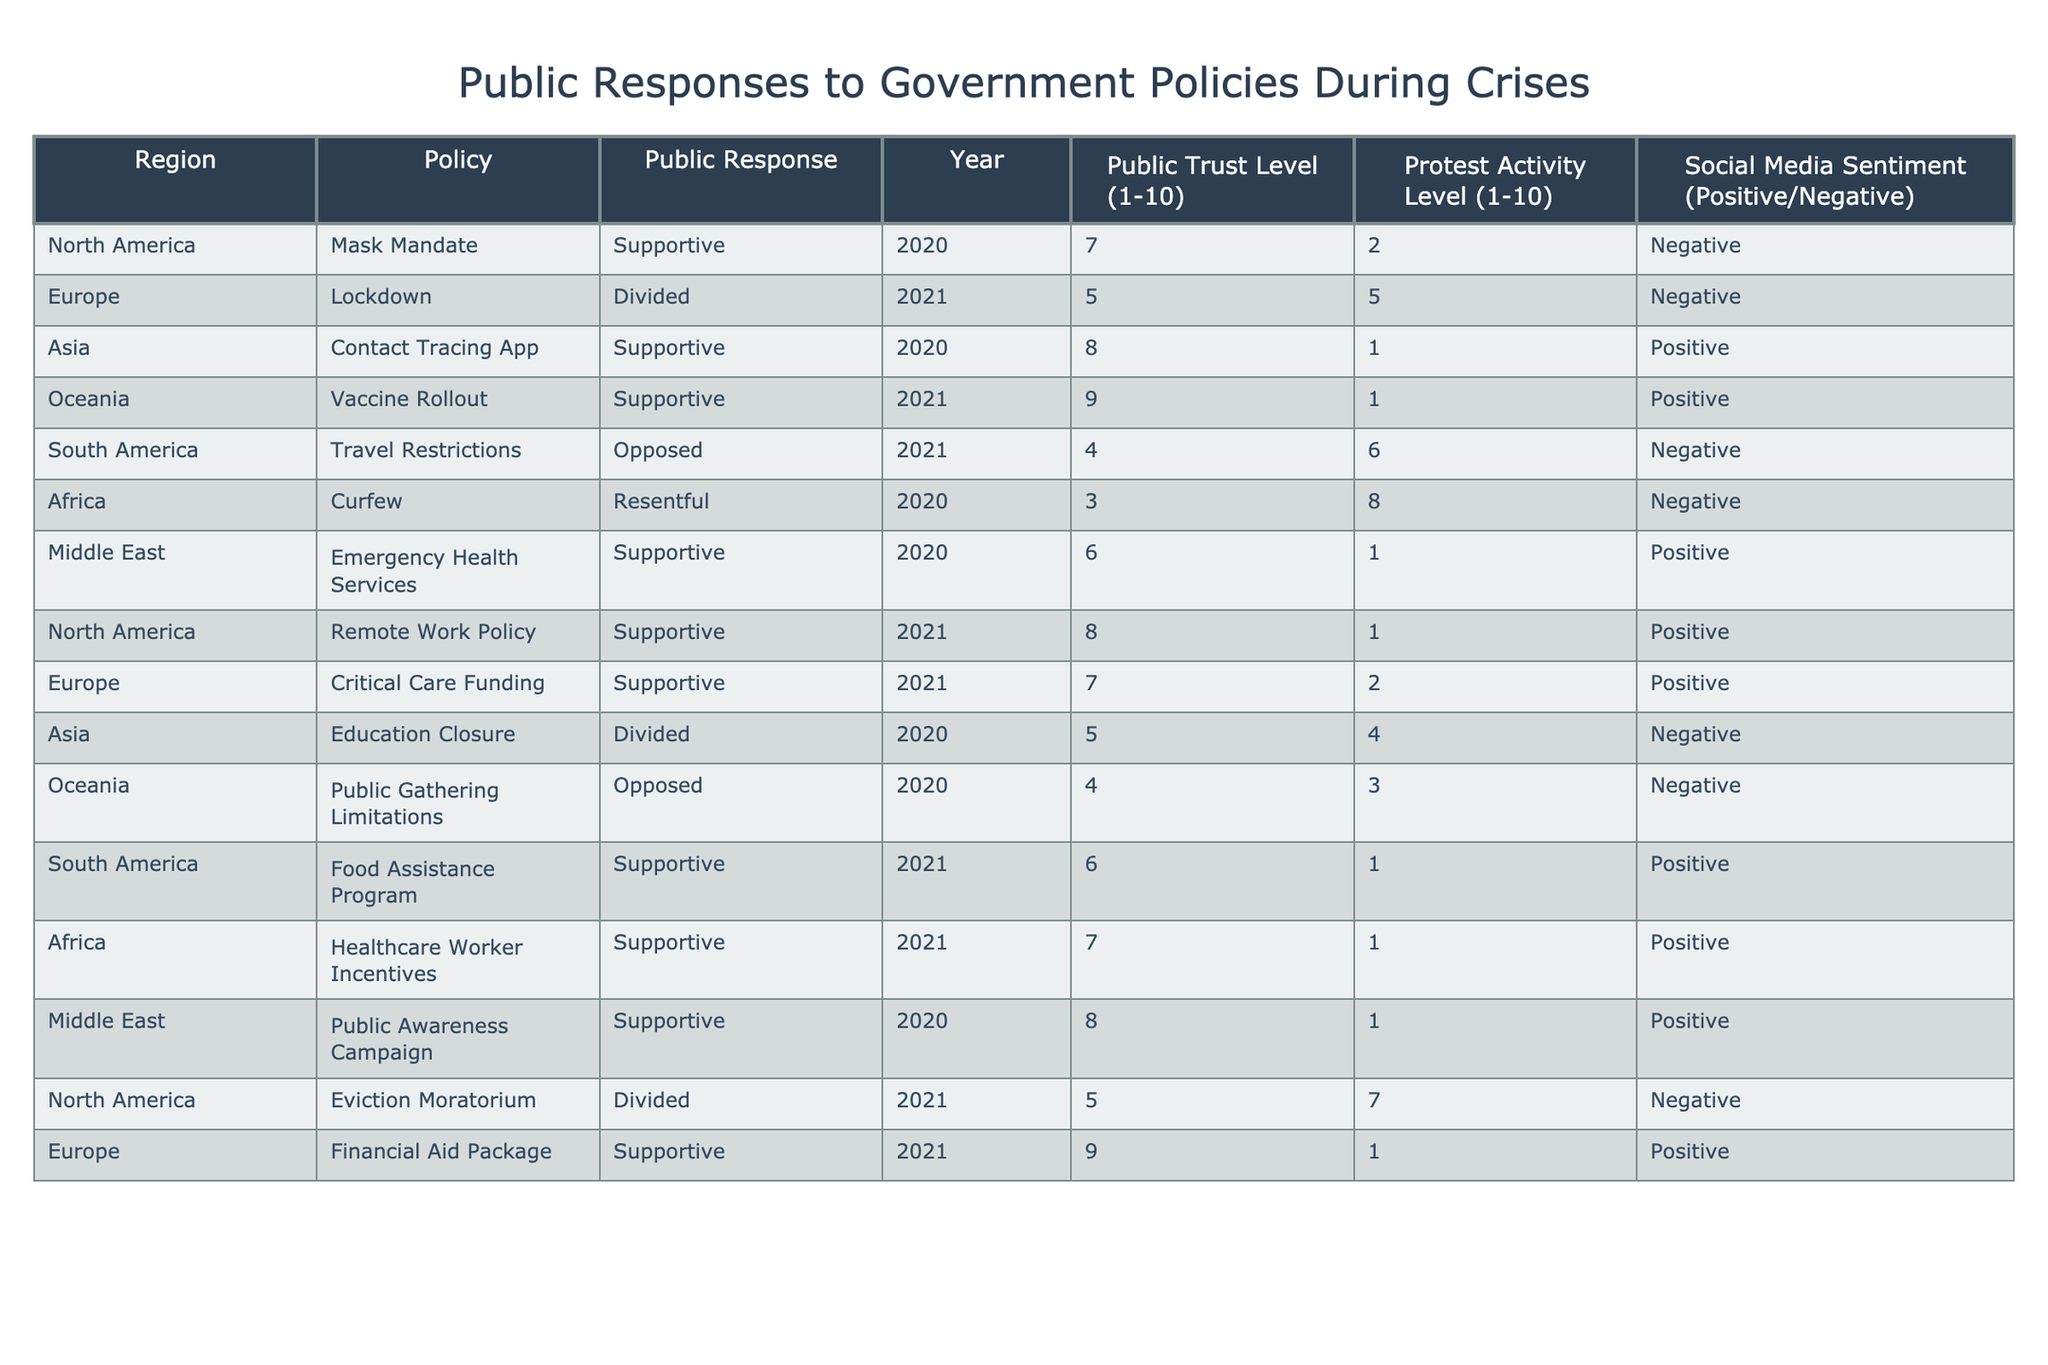What public response was recorded for the Mask Mandate in North America? The table shows that the public response to the Mask Mandate in North America was "Supportive."
Answer: Supportive Which region showed the highest Public Trust Level and what was the value? The table indicates that Oceania had the highest Public Trust Level with a value of 9.
Answer: 9 What is the average Public Trust Level across all regions? By adding the Public Trust Levels (7 + 5 + 8 + 9 + 4 + 3 + 6 + 6 + 7 + 5 + 8 + 9 = 6.5) and dividing by the number of regions (12), the average Public Trust Level is 6.5.
Answer: 6.5 Did any region oppose the Vaccine Rollout policy? The table shows that there were no records of opposition to the Vaccine Rollout; thus, the answer is false.
Answer: No Which region had the most protest activity, and what was the level? The table shows that Africa had the highest protest activity level with a value of 8.
Answer: Africa, 8 How many regions had a supportive public response to government policies? By counting all entries with "Supportive" in the Public Response field, which are 7 entries, we find that 7 regions had a supportive response.
Answer: 7 What was the social media sentiment regarding travel restrictions in South America? The table specifies that social media sentiment about travel restrictions in South America was "Negative."
Answer: Negative Which two regions had a divided public response, and what policies did they relate to? The table shows that North America (Eviction Moratorium) and Asia (Education Closure) had divided public responses.
Answer: North America (Eviction Moratorium) and Asia (Education Closure) What is the difference in protest activity levels between South America and Africa? The protest activity level in Africa is 8, while in South America, it is 6. Thus, the difference is 8 - 6 = 2.
Answer: 2 In how many instances was the public response "Resentful"? The table lists only one instance of a "Resentful" response, which is for the Curfew policy in Africa.
Answer: 1 